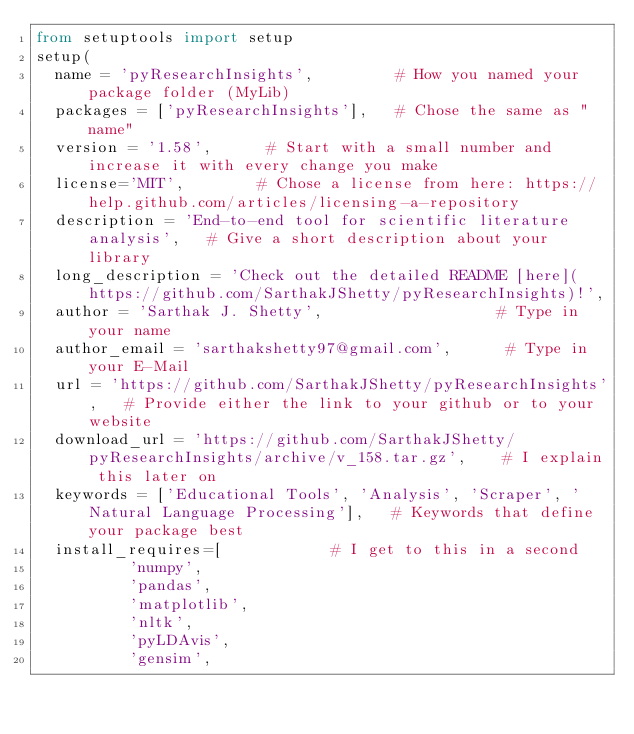<code> <loc_0><loc_0><loc_500><loc_500><_Python_>from setuptools import setup
setup(
  name = 'pyResearchInsights',         # How you named your package folder (MyLib)
  packages = ['pyResearchInsights'],   # Chose the same as "name"
  version = '1.58',      # Start with a small number and increase it with every change you make
  license='MIT',        # Chose a license from here: https://help.github.com/articles/licensing-a-repository
  description = 'End-to-end tool for scientific literature analysis',   # Give a short description about your library
  long_description = 'Check out the detailed README [here](https://github.com/SarthakJShetty/pyResearchInsights)!',
  author = 'Sarthak J. Shetty',                   # Type in your name
  author_email = 'sarthakshetty97@gmail.com',      # Type in your E-Mail
  url = 'https://github.com/SarthakJShetty/pyResearchInsights',   # Provide either the link to your github or to your website
  download_url = 'https://github.com/SarthakJShetty/pyResearchInsights/archive/v_158.tar.gz',    # I explain this later on
  keywords = ['Educational Tools', 'Analysis', 'Scraper', 'Natural Language Processing'],   # Keywords that define your package best
  install_requires=[            # I get to this in a second
          'numpy',
          'pandas',
          'matplotlib',
          'nltk',
          'pyLDAvis',
          'gensim',</code> 